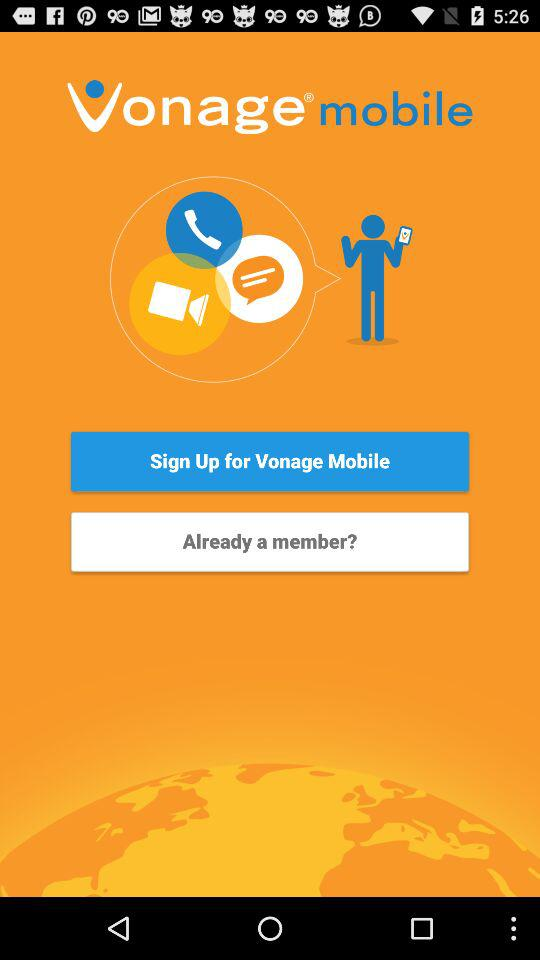What is the name of the application? The name of the application is "Vonage mobile". 